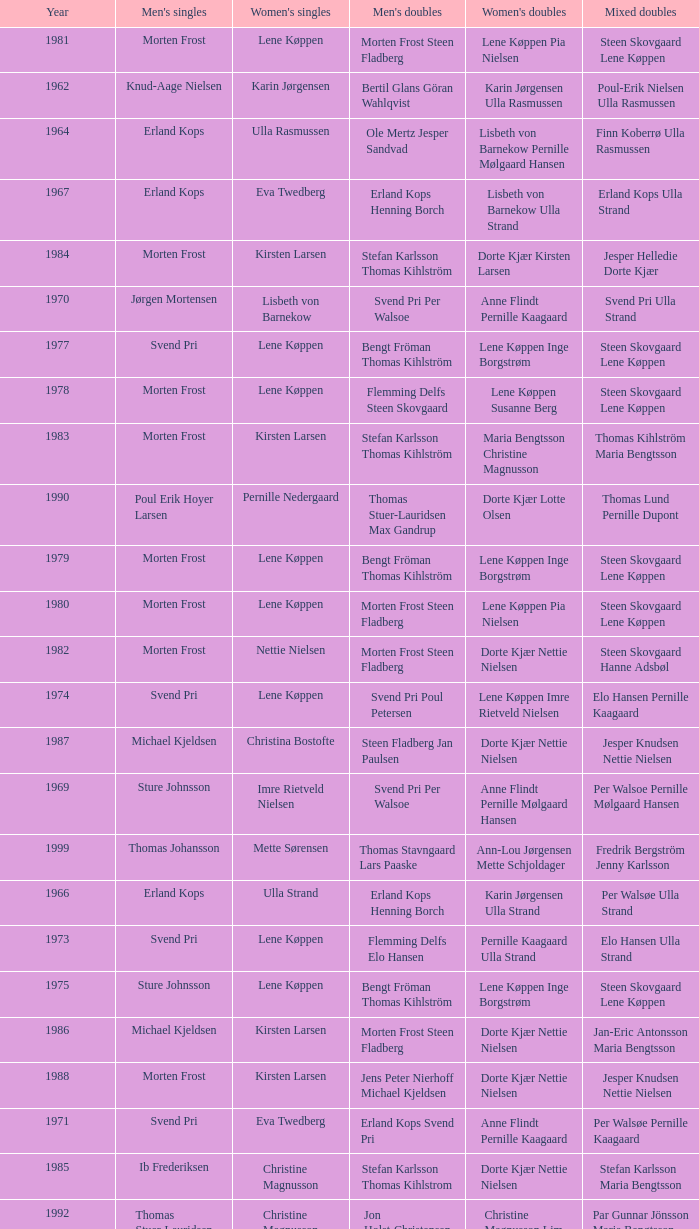Who won the men's doubles the year Pernille Nedergaard won the women's singles? Thomas Stuer-Lauridsen Max Gandrup. 